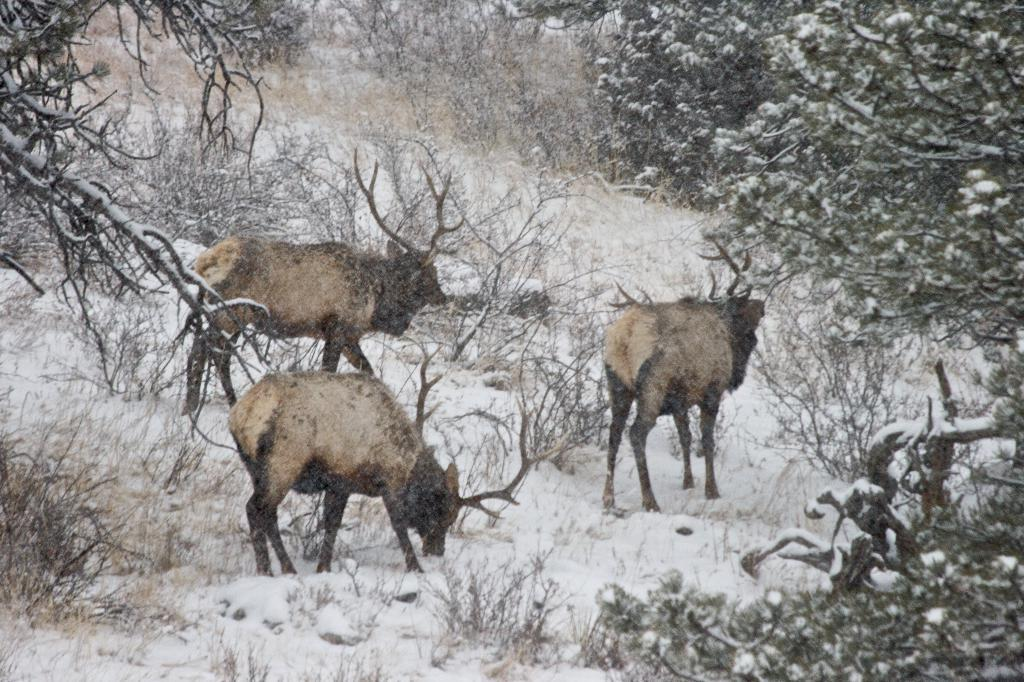What type of natural environment is depicted in the image? There are many trees and plants in the image, suggesting a natural environment. How many animals can be seen in the image? There are three animals in the image. What is the weather like in the image? There is snow visible in the image, indicating a cold or wintry environment. What type of badge is the pig wearing in the image? There is no pig present in the image, and therefore no badge can be observed. 